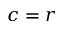<formula> <loc_0><loc_0><loc_500><loc_500>c = r</formula> 